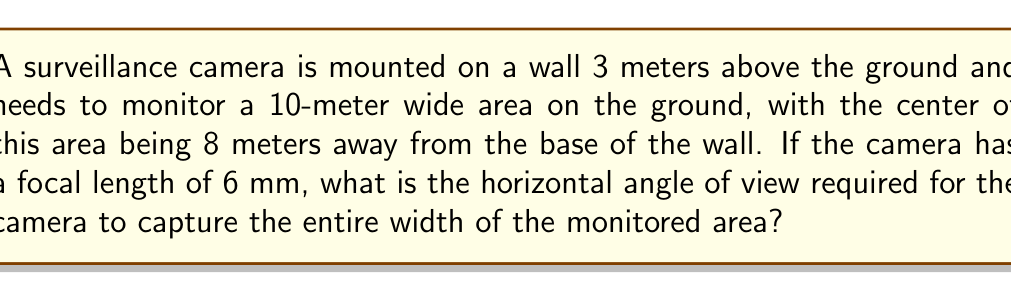Give your solution to this math problem. To solve this problem, we need to follow these steps:

1) First, let's visualize the scenario:

[asy]
import geometry;

unitsize(0.5cm);

// Draw the ground and wall
draw((0,0)--(20,0));
draw((0,0)--(0,6));

// Draw the camera and its field of view
dot((0,6));
draw((0,6)--(3,0));
draw((0,6)--(13,0));

// Label points
label("Camera", (0,6), W);
label("3m", (0,3), W);
label("8m", (4,0), S);
label("5m", (8,0), S);
label("5m", (12,0), S);

// Label angle
draw((1,6)..(2,5.5)..(3,6), Arrow);
label("$\theta$", (2,5.7), N);

[/asy]

2) We can see that this forms a right-angled triangle. The angle we're looking for is at the camera, between the two lines that reach the edges of the monitored area.

3) We can split this into two right-angled triangles, each covering half of the monitored width.

4) In one of these triangles:
   - The adjacent side is 8 meters (distance to the center of the monitored area)
   - The opposite side is 5 meters (half of the 10-meter wide area)
   - The hypotenuse goes from the camera to the edge of the monitored area

5) We can find half of our required angle using the arctangent function:

   $$\frac{\theta}{2} = \arctan(\frac{5}{8})$$

6) To get the full angle, we double this:

   $$\theta = 2 \arctan(\frac{5}{8})$$

7) Calculate:
   $$\theta = 2 \arctan(\frac{5}{8}) \approx 0.8621 \text{ radians}$$

8) Convert to degrees:
   $$\theta \approx 0.8621 \times \frac{180}{\pi} \approx 49.4°$$

9) Now, we need to relate this to the focal length. The angle of view (AOV) for a camera is given by:

   $$AOV = 2 \arctan(\frac{d}{2f})$$

   Where $d$ is the width of the image sensor and $f$ is the focal length.

10) Rearranging this formula, we can find the required sensor width:

    $$d = 2f \tan(\frac{AOV}{2})$$

11) Substituting our values:

    $$d = 2 \times 6 \times \tan(\frac{49.4°}{2}) \approx 5.15 \text{ mm}$$

Therefore, to capture the required area with a 6 mm focal length, the camera needs a horizontal angle of view of approximately 49.4°, which corresponds to an image sensor width of about 5.15 mm.
Answer: 49.4° 